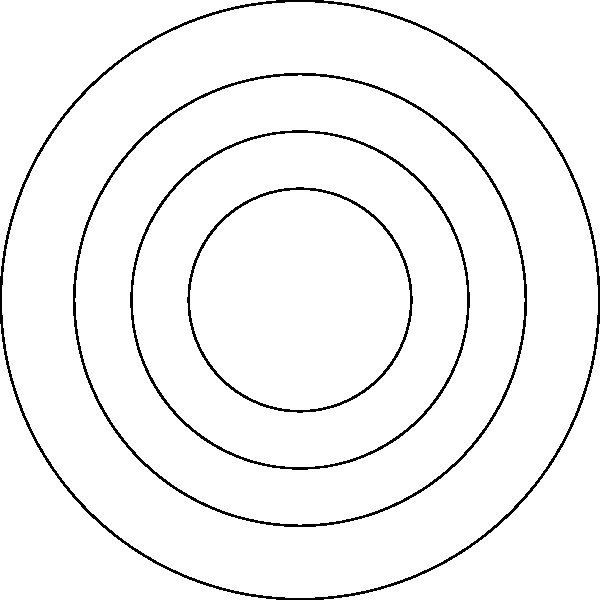Based on the topographical map of Khalino shown above, what can be inferred about the terrain between Khalino Peak and the nearby town? To answer this question, we need to analyze the contour lines on the map:

1. Identify key features:
   - Khalino Peak is at the center (0,0)
   - The town is located at approximately (30,-30)

2. Interpret contour lines:
   - Contour lines represent points of equal elevation
   - Closer lines indicate steeper slopes
   - Lines further apart indicate gentler slopes

3. Analyze the terrain between Khalino Peak and the town:
   - The contour lines are closer together near Khalino Peak
   - They become more spread out as we move towards the town

4. Draw conclusions:
   - The terrain is steepest near Khalino Peak
   - It becomes gradually less steep (more gentle) as we move towards the town
   - This indicates a downhill slope from Khalino Peak to the town

Therefore, the terrain between Khalino Peak and the nearby town can be described as a gradual downhill slope, with the steepest part near the peak and becoming more gentle towards the town.
Answer: Gradual downhill slope, steeper near the peak 